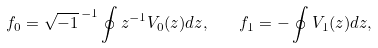Convert formula to latex. <formula><loc_0><loc_0><loc_500><loc_500>f _ { 0 } = \sqrt { - 1 } ^ { \, - 1 } \oint z ^ { - 1 } V _ { 0 } ( z ) d z , \quad f _ { 1 } = - \oint V _ { 1 } ( z ) d z ,</formula> 